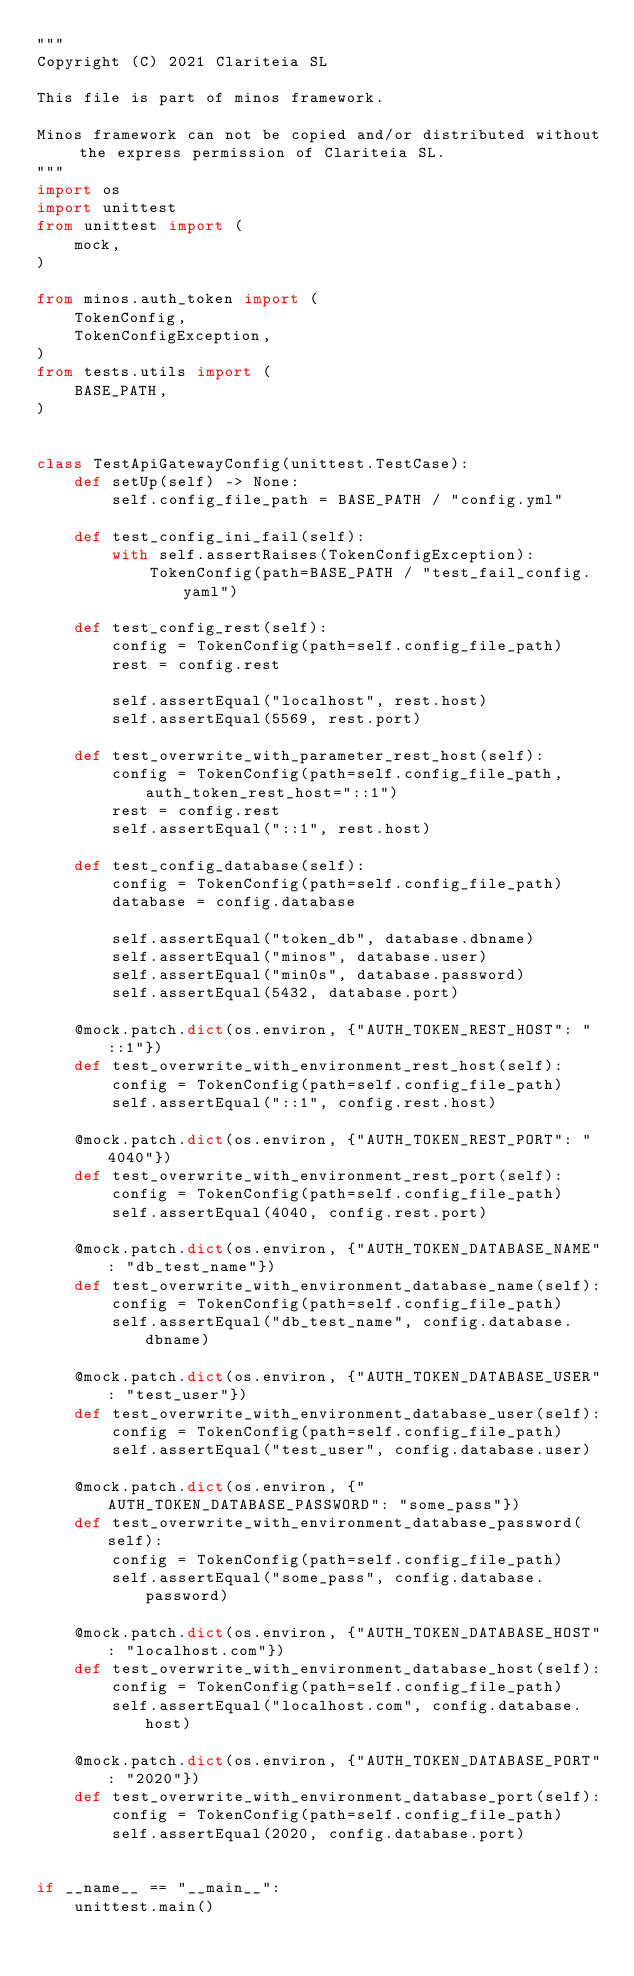Convert code to text. <code><loc_0><loc_0><loc_500><loc_500><_Python_>"""
Copyright (C) 2021 Clariteia SL

This file is part of minos framework.

Minos framework can not be copied and/or distributed without the express permission of Clariteia SL.
"""
import os
import unittest
from unittest import (
    mock,
)

from minos.auth_token import (
    TokenConfig,
    TokenConfigException,
)
from tests.utils import (
    BASE_PATH,
)


class TestApiGatewayConfig(unittest.TestCase):
    def setUp(self) -> None:
        self.config_file_path = BASE_PATH / "config.yml"

    def test_config_ini_fail(self):
        with self.assertRaises(TokenConfigException):
            TokenConfig(path=BASE_PATH / "test_fail_config.yaml")

    def test_config_rest(self):
        config = TokenConfig(path=self.config_file_path)
        rest = config.rest

        self.assertEqual("localhost", rest.host)
        self.assertEqual(5569, rest.port)

    def test_overwrite_with_parameter_rest_host(self):
        config = TokenConfig(path=self.config_file_path, auth_token_rest_host="::1")
        rest = config.rest
        self.assertEqual("::1", rest.host)

    def test_config_database(self):
        config = TokenConfig(path=self.config_file_path)
        database = config.database

        self.assertEqual("token_db", database.dbname)
        self.assertEqual("minos", database.user)
        self.assertEqual("min0s", database.password)
        self.assertEqual(5432, database.port)

    @mock.patch.dict(os.environ, {"AUTH_TOKEN_REST_HOST": "::1"})
    def test_overwrite_with_environment_rest_host(self):
        config = TokenConfig(path=self.config_file_path)
        self.assertEqual("::1", config.rest.host)

    @mock.patch.dict(os.environ, {"AUTH_TOKEN_REST_PORT": "4040"})
    def test_overwrite_with_environment_rest_port(self):
        config = TokenConfig(path=self.config_file_path)
        self.assertEqual(4040, config.rest.port)

    @mock.patch.dict(os.environ, {"AUTH_TOKEN_DATABASE_NAME": "db_test_name"})
    def test_overwrite_with_environment_database_name(self):
        config = TokenConfig(path=self.config_file_path)
        self.assertEqual("db_test_name", config.database.dbname)

    @mock.patch.dict(os.environ, {"AUTH_TOKEN_DATABASE_USER": "test_user"})
    def test_overwrite_with_environment_database_user(self):
        config = TokenConfig(path=self.config_file_path)
        self.assertEqual("test_user", config.database.user)

    @mock.patch.dict(os.environ, {"AUTH_TOKEN_DATABASE_PASSWORD": "some_pass"})
    def test_overwrite_with_environment_database_password(self):
        config = TokenConfig(path=self.config_file_path)
        self.assertEqual("some_pass", config.database.password)

    @mock.patch.dict(os.environ, {"AUTH_TOKEN_DATABASE_HOST": "localhost.com"})
    def test_overwrite_with_environment_database_host(self):
        config = TokenConfig(path=self.config_file_path)
        self.assertEqual("localhost.com", config.database.host)

    @mock.patch.dict(os.environ, {"AUTH_TOKEN_DATABASE_PORT": "2020"})
    def test_overwrite_with_environment_database_port(self):
        config = TokenConfig(path=self.config_file_path)
        self.assertEqual(2020, config.database.port)


if __name__ == "__main__":
    unittest.main()
</code> 